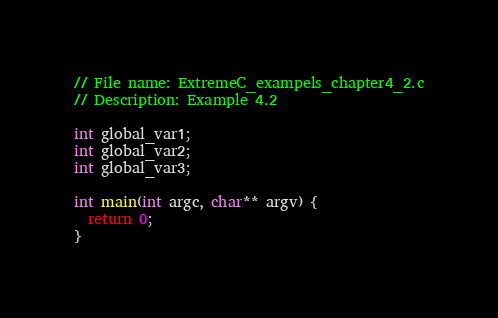<code> <loc_0><loc_0><loc_500><loc_500><_C_>// File name: ExtremeC_exampels_chapter4_2.c
// Description: Example 4.2

int global_var1;
int global_var2;
int global_var3;

int main(int argc, char** argv) {
  return 0;
}
</code> 